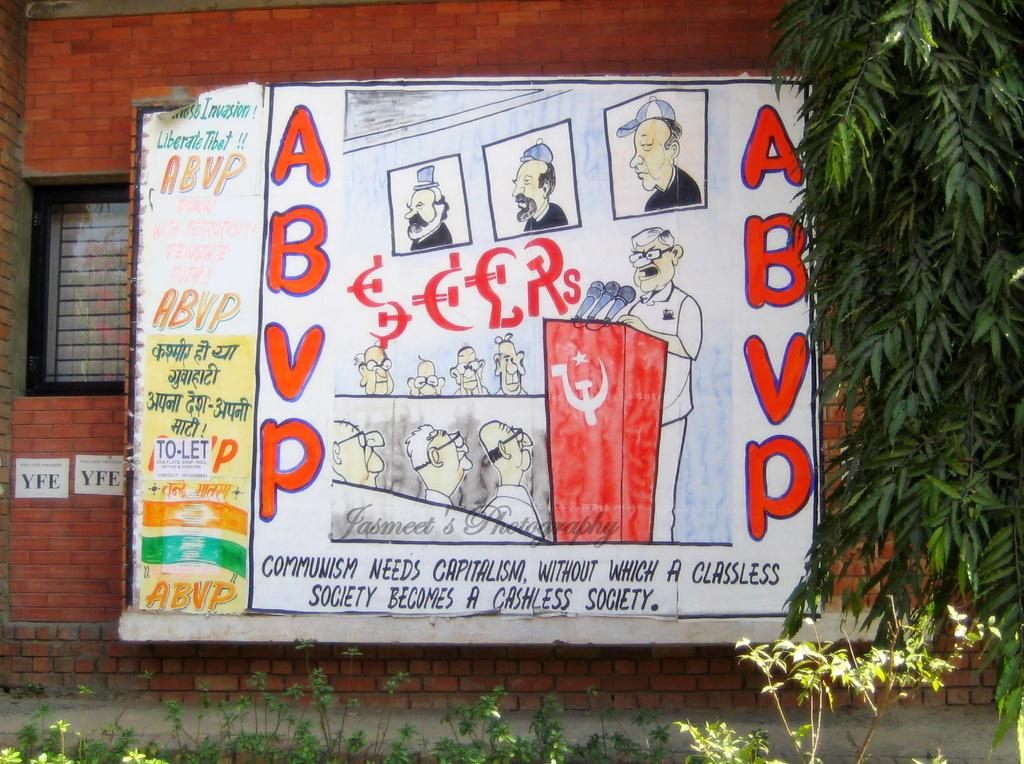What is the main subject in the center of the image? There is a poster in the center of the image. What can be seen on the poster? There are people depicted on the poster, and there is writing on the poster. What can be seen in the background of the image? There is a wall, a window, trees, and plants in the background of the image. How much honey is being produced by the bees in the image? There are no bees or honey present in the image; it features a poster with people and writing. How long does it take for the minute hand to move one minute in the image? There is no clock or time-related element in the image, so it is not possible to determine how long it takes for the minute hand to move one minute. 